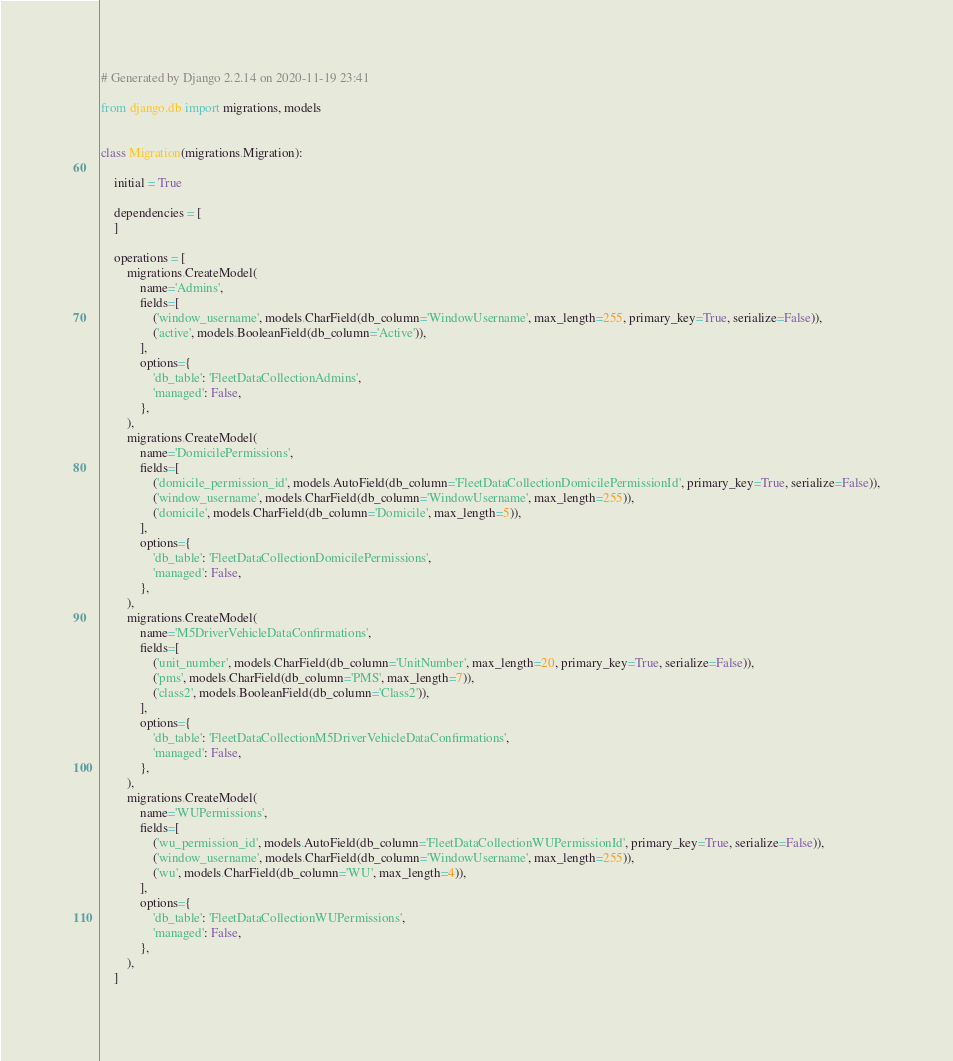Convert code to text. <code><loc_0><loc_0><loc_500><loc_500><_Python_># Generated by Django 2.2.14 on 2020-11-19 23:41

from django.db import migrations, models


class Migration(migrations.Migration):

    initial = True

    dependencies = [
    ]

    operations = [
        migrations.CreateModel(
            name='Admins',
            fields=[
                ('window_username', models.CharField(db_column='WindowUsername', max_length=255, primary_key=True, serialize=False)),
                ('active', models.BooleanField(db_column='Active')),
            ],
            options={
                'db_table': 'FleetDataCollectionAdmins',
                'managed': False,
            },
        ),
        migrations.CreateModel(
            name='DomicilePermissions',
            fields=[
                ('domicile_permission_id', models.AutoField(db_column='FleetDataCollectionDomicilePermissionId', primary_key=True, serialize=False)),
                ('window_username', models.CharField(db_column='WindowUsername', max_length=255)),
                ('domicile', models.CharField(db_column='Domicile', max_length=5)),
            ],
            options={
                'db_table': 'FleetDataCollectionDomicilePermissions',
                'managed': False,
            },
        ),
        migrations.CreateModel(
            name='M5DriverVehicleDataConfirmations',
            fields=[
                ('unit_number', models.CharField(db_column='UnitNumber', max_length=20, primary_key=True, serialize=False)),
                ('pms', models.CharField(db_column='PMS', max_length=7)),
                ('class2', models.BooleanField(db_column='Class2')),
            ],
            options={
                'db_table': 'FleetDataCollectionM5DriverVehicleDataConfirmations',
                'managed': False,
            },
        ),
        migrations.CreateModel(
            name='WUPermissions',
            fields=[
                ('wu_permission_id', models.AutoField(db_column='FleetDataCollectionWUPermissionId', primary_key=True, serialize=False)),
                ('window_username', models.CharField(db_column='WindowUsername', max_length=255)),
                ('wu', models.CharField(db_column='WU', max_length=4)),
            ],
            options={
                'db_table': 'FleetDataCollectionWUPermissions',
                'managed': False,
            },
        ),
    ]
</code> 